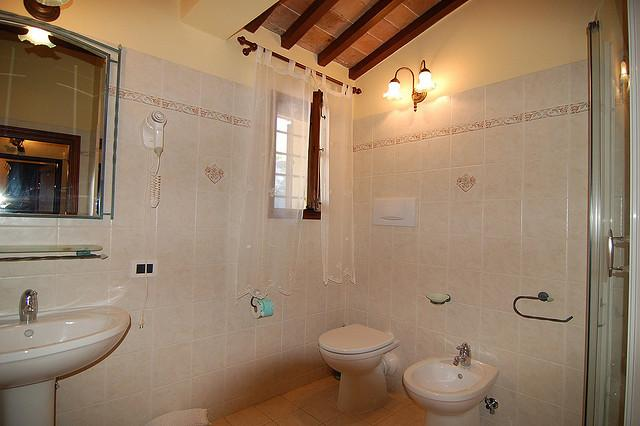How many places could an animal get water from here? Please explain your reasoning. three. An animal could get water from the sink, toilet, or bidet. 